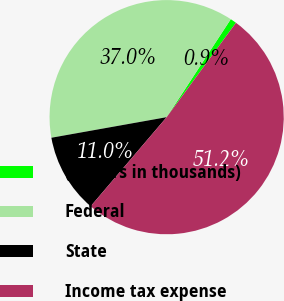Convert chart to OTSL. <chart><loc_0><loc_0><loc_500><loc_500><pie_chart><fcel>(Dollars in thousands)<fcel>Federal<fcel>State<fcel>Income tax expense<nl><fcel>0.86%<fcel>37.03%<fcel>10.95%<fcel>51.15%<nl></chart> 